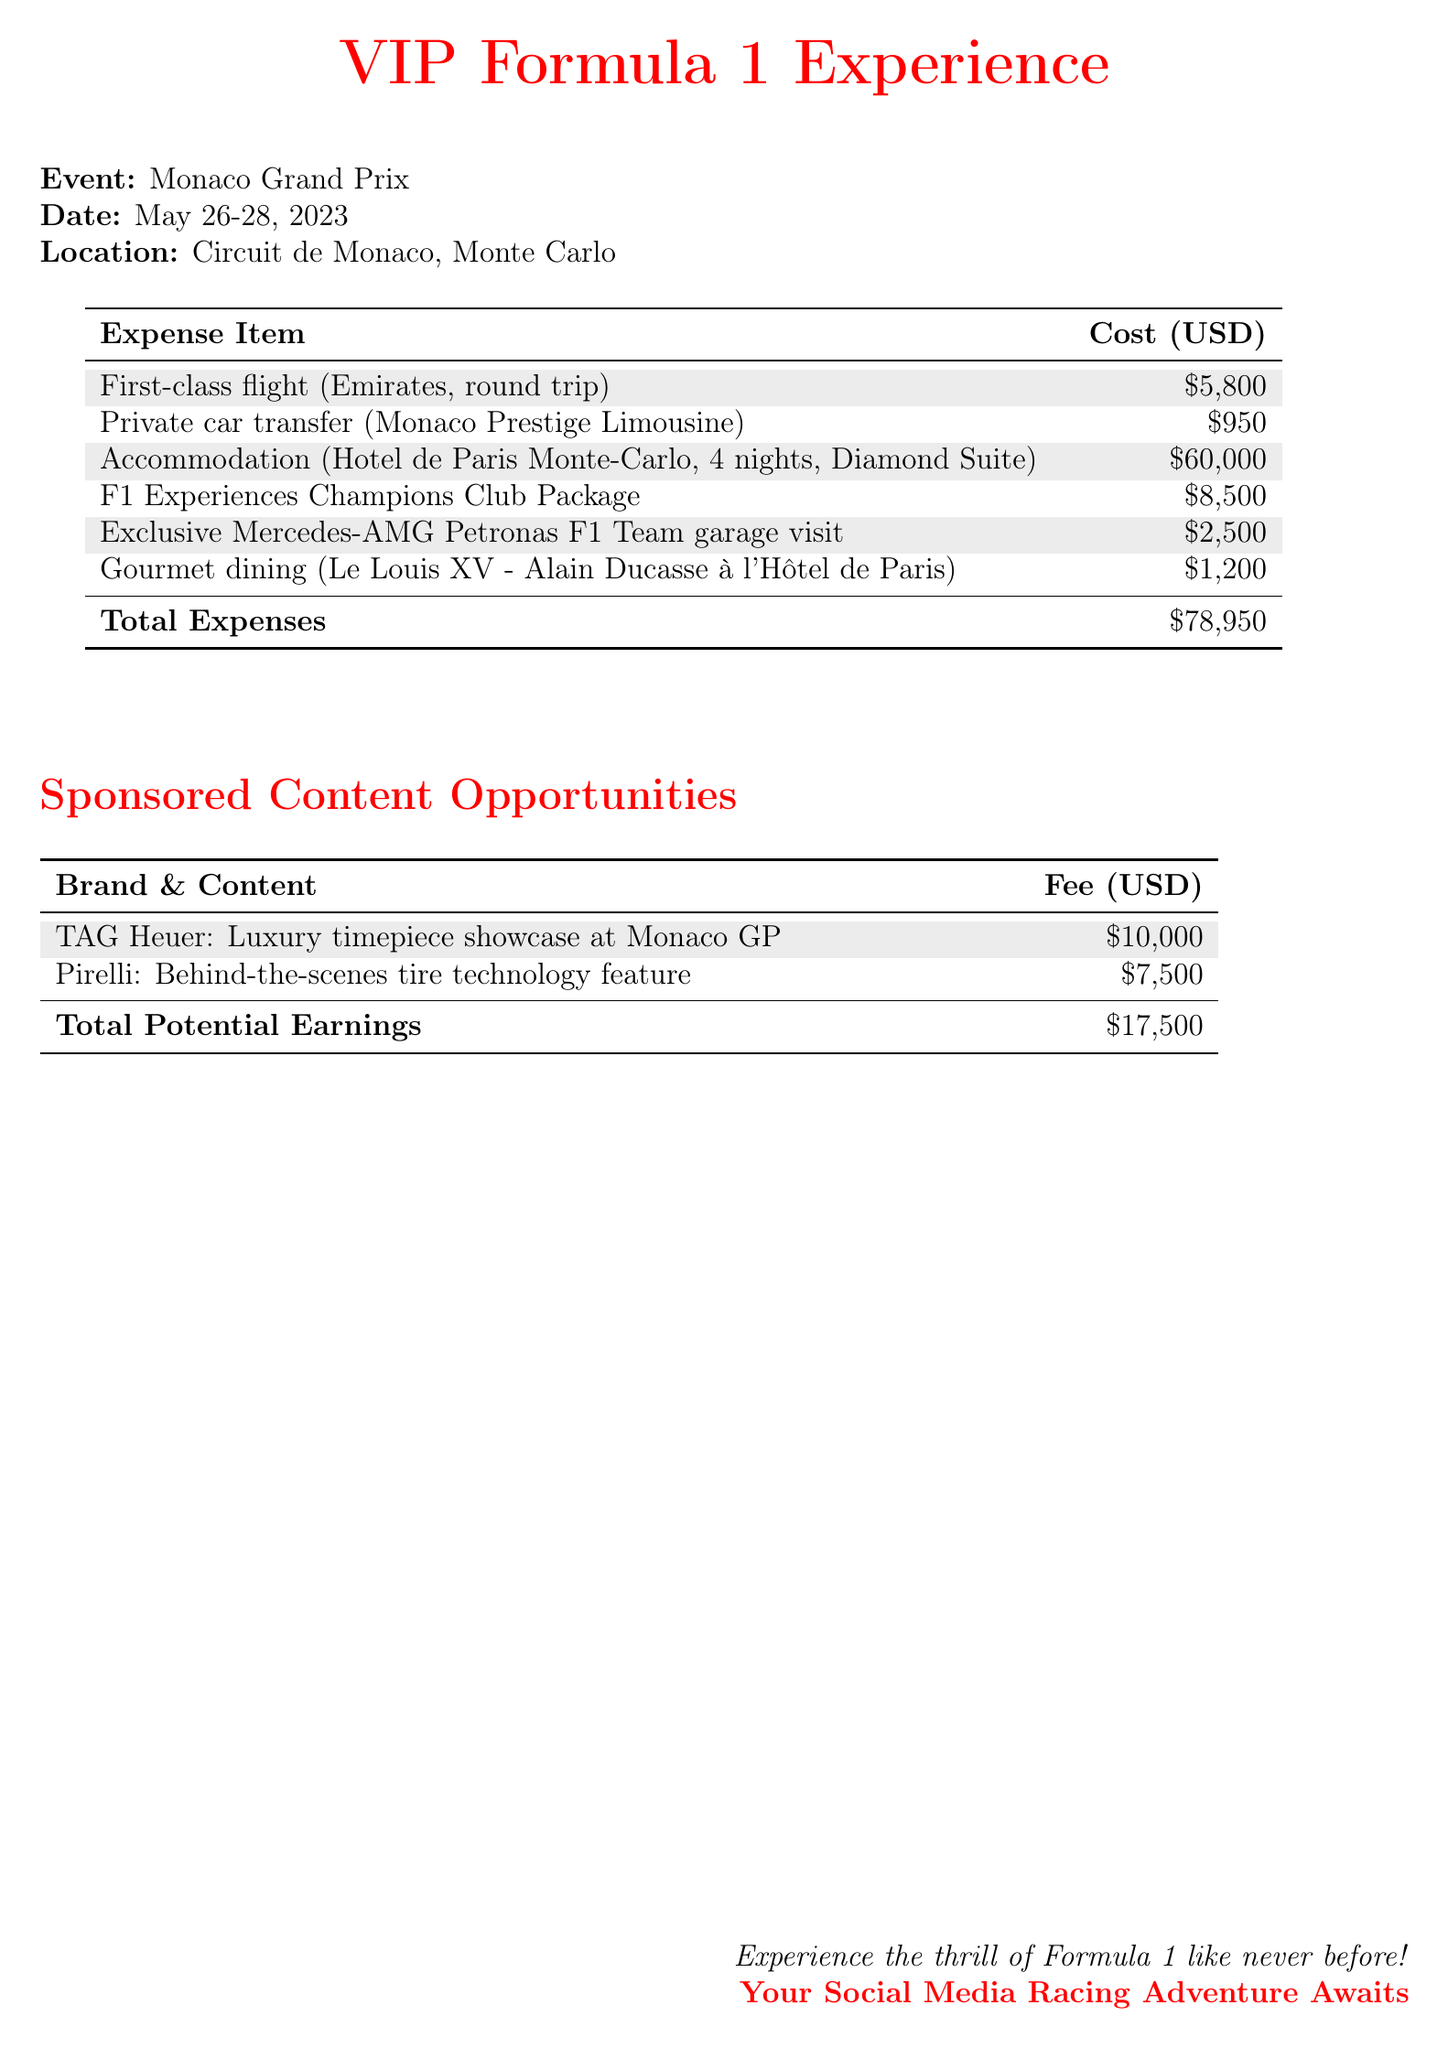What is the event? The event is specified in the document as the Monaco Grand Prix.
Answer: Monaco Grand Prix What are the dates of the event? The document lists the dates of the event as May 26-28, 2023.
Answer: May 26-28, 2023 What is the accommodation cost? The accommodation cost is explicitly stated as $60,000 for the stay.
Answer: $60,000 How much was spent on the exclusive garage visit? The cost for the exclusive Mercedes-AMG Petronas F1 Team garage visit is indicated in the document.
Answer: $2,500 What is the total expense? The document provides a summation of all expenses listed for the VIP experience.
Answer: $78,950 What is the total potential earnings from brand collaborations? The total potential earnings are calculated from the specified fees for sponsorship opportunities.
Answer: $17,500 Which airline was used for the flight? The document states the airline used for the first-class flight.
Answer: Emirates What type of dining experience was mentioned? The document mentions a specific dining experience at a high-end restaurant.
Answer: Gourmet dining What is included in the F1 Experiences Champions Club Package? This question asks broadly but based on the document, it refers to a specific item in the expense report.
Answer: F1 Experiences Champions Club Package 